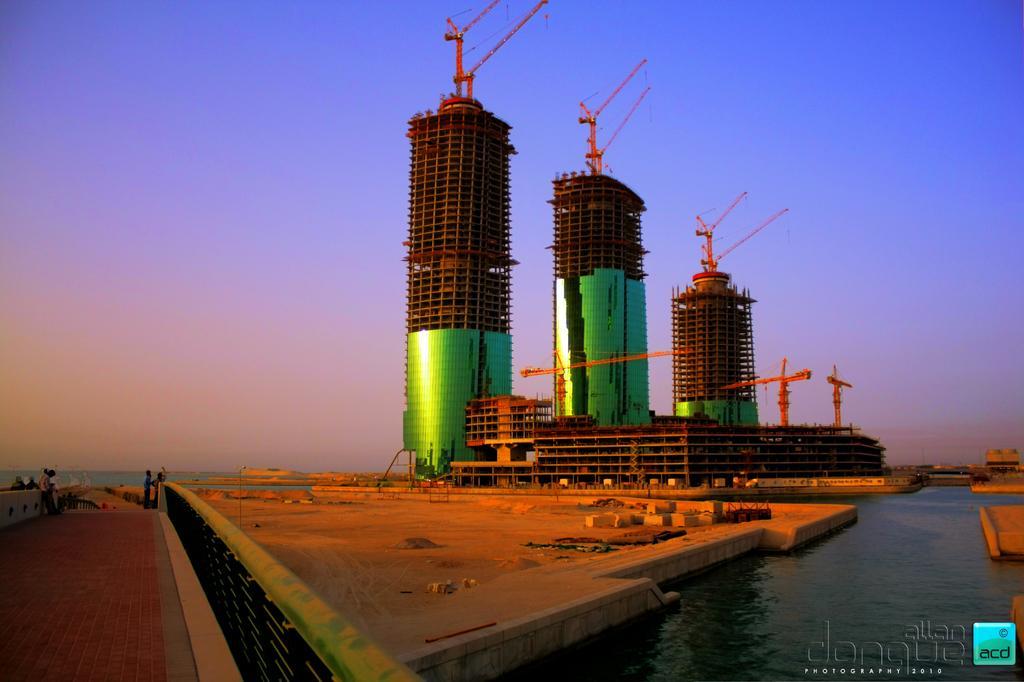Describe this image in one or two sentences. In this image I can see under constructed buildings , in front of the buildings I can see the lake and on the left side I can see a bridge, on the bridge I can see persons ,at the top I can see the sky. 